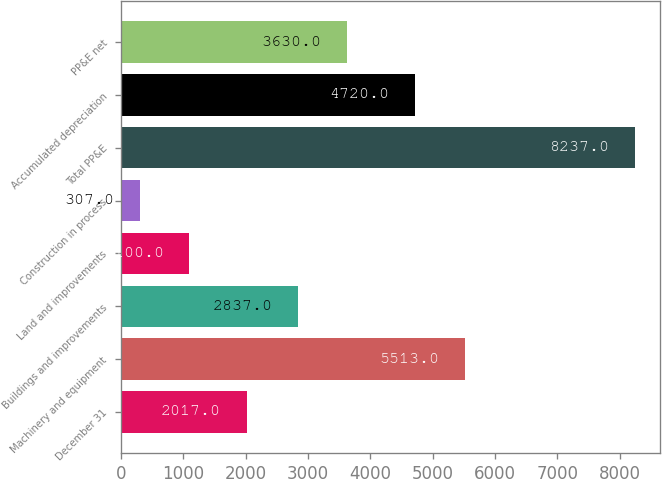<chart> <loc_0><loc_0><loc_500><loc_500><bar_chart><fcel>December 31<fcel>Machinery and equipment<fcel>Buildings and improvements<fcel>Land and improvements<fcel>Construction in process<fcel>Total PP&E<fcel>Accumulated depreciation<fcel>PP&E net<nl><fcel>2017<fcel>5513<fcel>2837<fcel>1100<fcel>307<fcel>8237<fcel>4720<fcel>3630<nl></chart> 